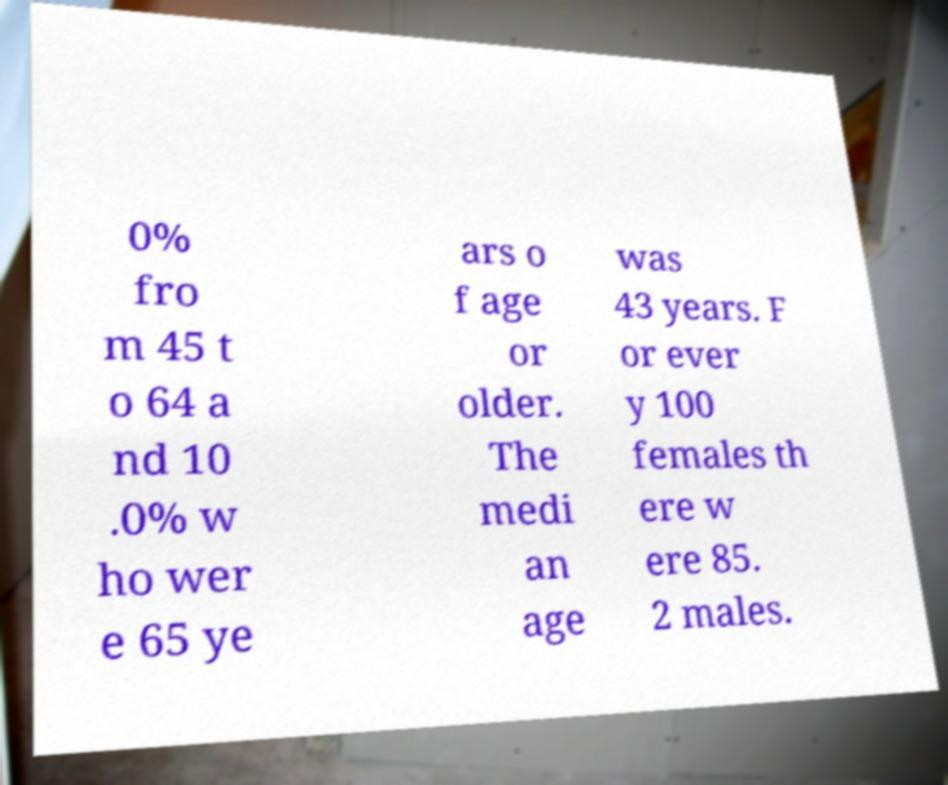Please read and relay the text visible in this image. What does it say? 0% fro m 45 t o 64 a nd 10 .0% w ho wer e 65 ye ars o f age or older. The medi an age was 43 years. F or ever y 100 females th ere w ere 85. 2 males. 